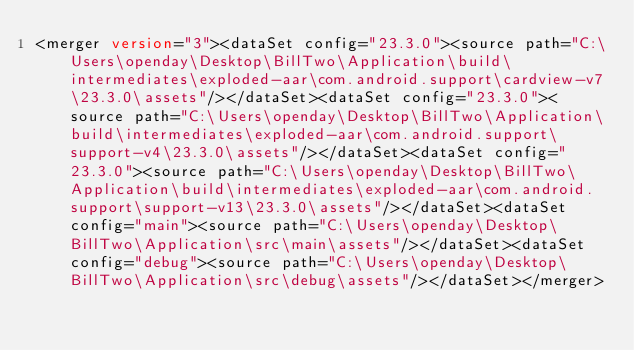<code> <loc_0><loc_0><loc_500><loc_500><_XML_><merger version="3"><dataSet config="23.3.0"><source path="C:\Users\openday\Desktop\BillTwo\Application\build\intermediates\exploded-aar\com.android.support\cardview-v7\23.3.0\assets"/></dataSet><dataSet config="23.3.0"><source path="C:\Users\openday\Desktop\BillTwo\Application\build\intermediates\exploded-aar\com.android.support\support-v4\23.3.0\assets"/></dataSet><dataSet config="23.3.0"><source path="C:\Users\openday\Desktop\BillTwo\Application\build\intermediates\exploded-aar\com.android.support\support-v13\23.3.0\assets"/></dataSet><dataSet config="main"><source path="C:\Users\openday\Desktop\BillTwo\Application\src\main\assets"/></dataSet><dataSet config="debug"><source path="C:\Users\openday\Desktop\BillTwo\Application\src\debug\assets"/></dataSet></merger></code> 